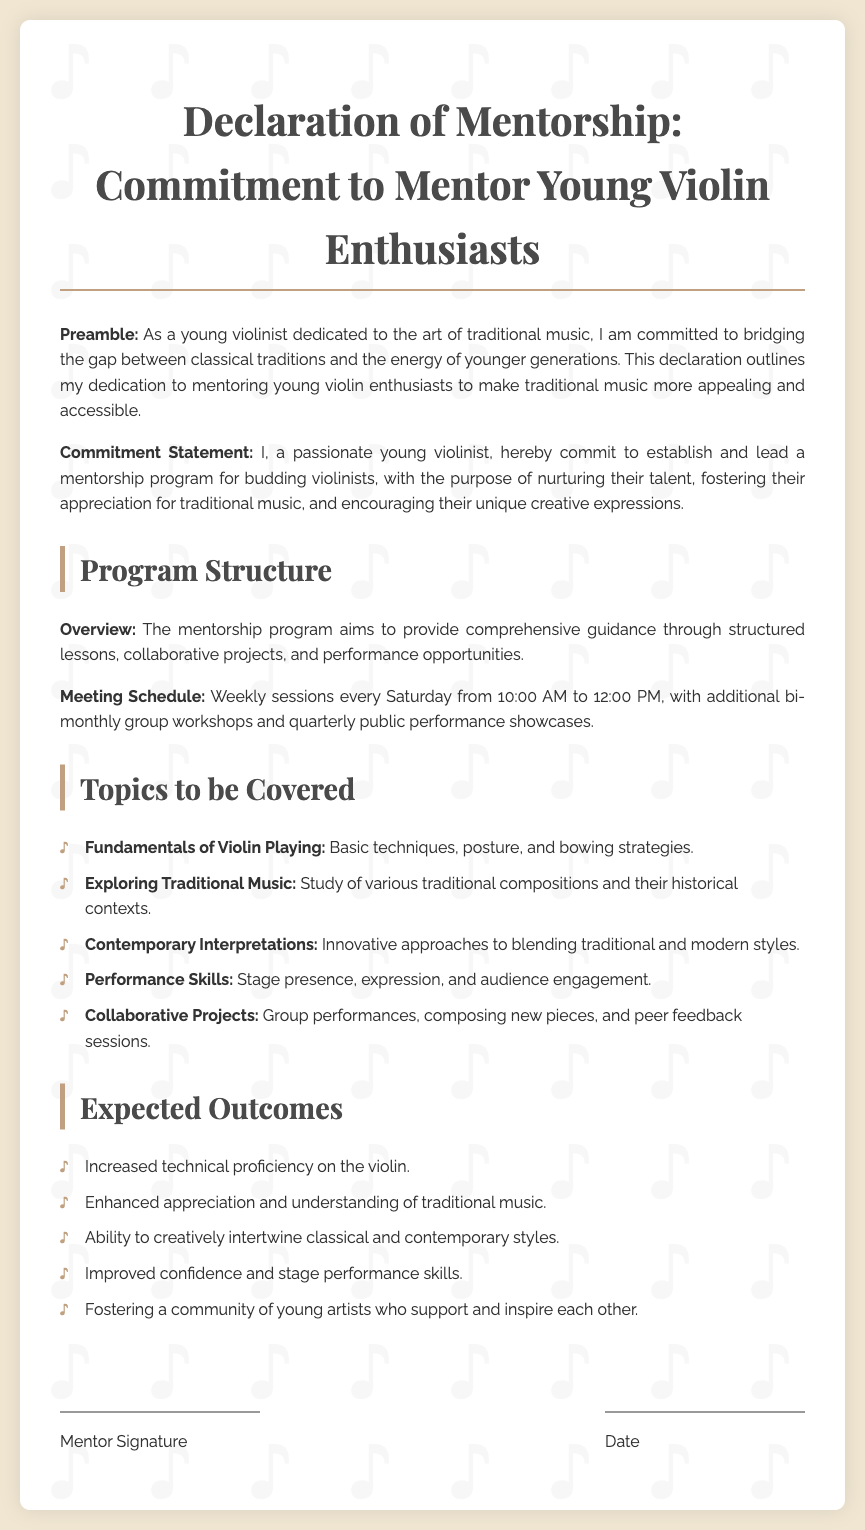What is the title of the document? The title is stated at the top of the document in a prominent position.
Answer: Declaration of Mentorship: Commitment to Mentor Young Violin Enthusiasts What day does the mentorship program meet? The meeting schedule specifies the exact day of the week for the sessions.
Answer: Saturday What time do the weekly sessions start? The document provides the specific start time for the sessions.
Answer: 10:00 AM How often are the group workshops held? The document indicates the frequency of the workshops in relation to the main meetings.
Answer: Bi-monthly What is one of the expected outcomes of the mentorship program? The outcomes reveal what participants are expected to achieve through the program.
Answer: Increased technical proficiency on the violin Name a topic covered in the mentorship program. The document lists specific themes that will be included in the mentorship.
Answer: Fundamentals of Violin Playing What type of projects are included in the program? The document describes the nature of collaborative work participants will engage in.
Answer: Collaborative Projects What is the primary purpose of the mentorship program? The preamble outlines the main goal of the mentorship initiative.
Answer: Nurturing their talent 